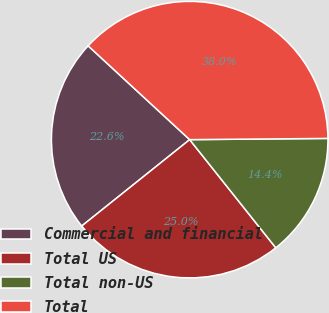Convert chart to OTSL. <chart><loc_0><loc_0><loc_500><loc_500><pie_chart><fcel>Commercial and financial<fcel>Total US<fcel>Total non-US<fcel>Total<nl><fcel>22.61%<fcel>24.96%<fcel>14.44%<fcel>37.99%<nl></chart> 